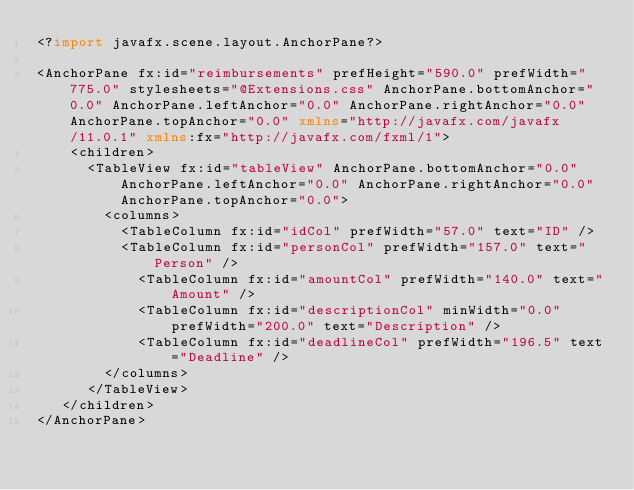Convert code to text. <code><loc_0><loc_0><loc_500><loc_500><_XML_><?import javafx.scene.layout.AnchorPane?>

<AnchorPane fx:id="reimbursements" prefHeight="590.0" prefWidth="775.0" stylesheets="@Extensions.css" AnchorPane.bottomAnchor="0.0" AnchorPane.leftAnchor="0.0" AnchorPane.rightAnchor="0.0" AnchorPane.topAnchor="0.0" xmlns="http://javafx.com/javafx/11.0.1" xmlns:fx="http://javafx.com/fxml/1">
    <children>
      <TableView fx:id="tableView" AnchorPane.bottomAnchor="0.0" AnchorPane.leftAnchor="0.0" AnchorPane.rightAnchor="0.0" AnchorPane.topAnchor="0.0">
        <columns>
          <TableColumn fx:id="idCol" prefWidth="57.0" text="ID" />
          <TableColumn fx:id="personCol" prefWidth="157.0" text="Person" />
            <TableColumn fx:id="amountCol" prefWidth="140.0" text="Amount" />
            <TableColumn fx:id="descriptionCol" minWidth="0.0" prefWidth="200.0" text="Description" />
            <TableColumn fx:id="deadlineCol" prefWidth="196.5" text="Deadline" />
        </columns>
      </TableView>
   </children>
</AnchorPane>
</code> 